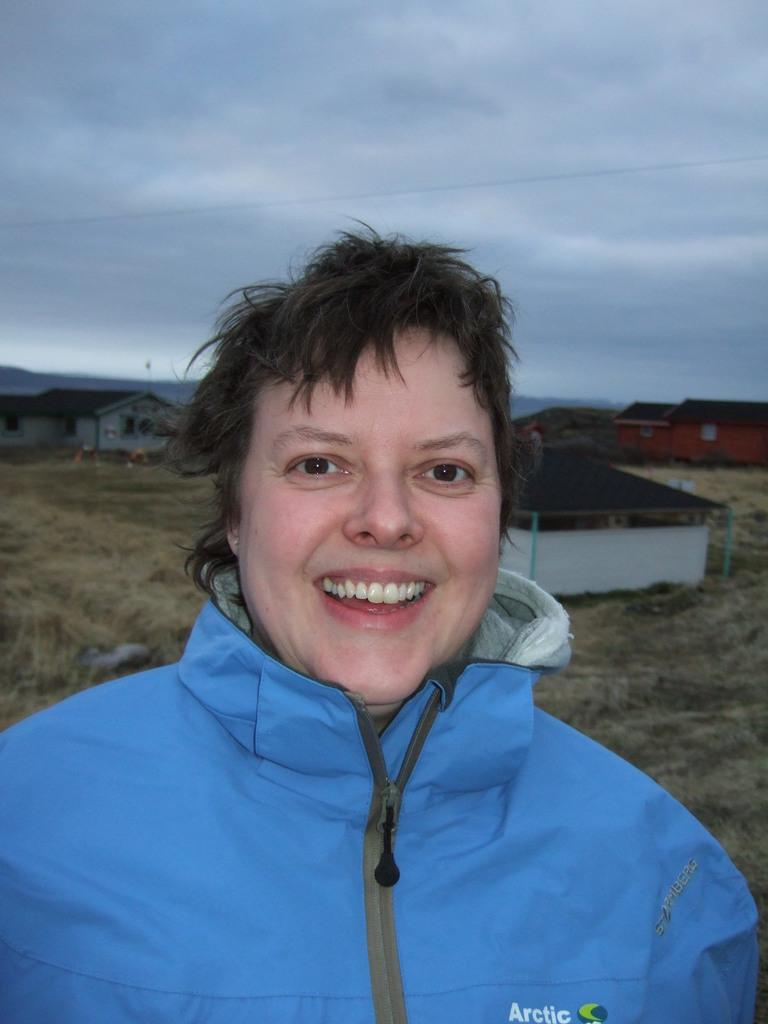Who is present in the image? There is a woman in the image. What is the woman's expression in the image? The woman is smiling in the image. What can be seen in the background of the image? There are buildings and clouds visible in the background of the image. What type of tools does the carpenter use in the image? There is no carpenter present in the image, so it is not possible to answer that question. 